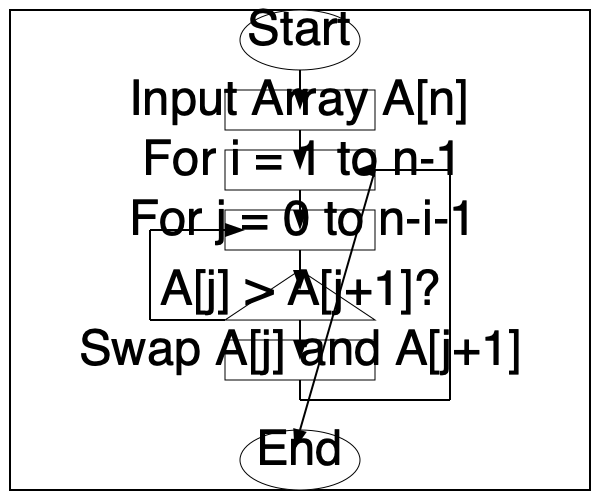Analyze the flowchart provided and determine which classic sorting algorithm it represents. What is the time complexity of this algorithm in Big O notation? To identify the sorting algorithm and determine its time complexity, let's analyze the flowchart step-by-step:

1. The flowchart shows a nested loop structure, which is common in comparison-based sorting algorithms.

2. The outer loop runs from 1 to n-1, where n is the size of the input array.

3. The inner loop runs from 0 to n-i-1, where i is the current iteration of the outer loop.

4. Inside the inner loop, there's a comparison between adjacent elements (A[j] and A[j+1]).

5. If A[j] > A[j+1], the elements are swapped.

6. This process continues until the entire array is sorted.

These characteristics clearly identify the algorithm as Bubble Sort. 

To determine the time complexity:

1. The outer loop runs (n-1) times.
2. For each iteration of the outer loop, the inner loop runs (n-i) times.
3. This results in a total number of comparisons:
   $$(n-1) + (n-2) + (n-3) + ... + 2 + 1 = \frac{n(n-1)}{2}$$

4. The summation above simplifies to $\frac{n^2}{2} - \frac{n}{2}$.

5. In Big O notation, we only consider the highest order term and discard constants.

Therefore, the time complexity of this algorithm (Bubble Sort) is $O(n^2)$.
Answer: Bubble Sort, $O(n^2)$ 